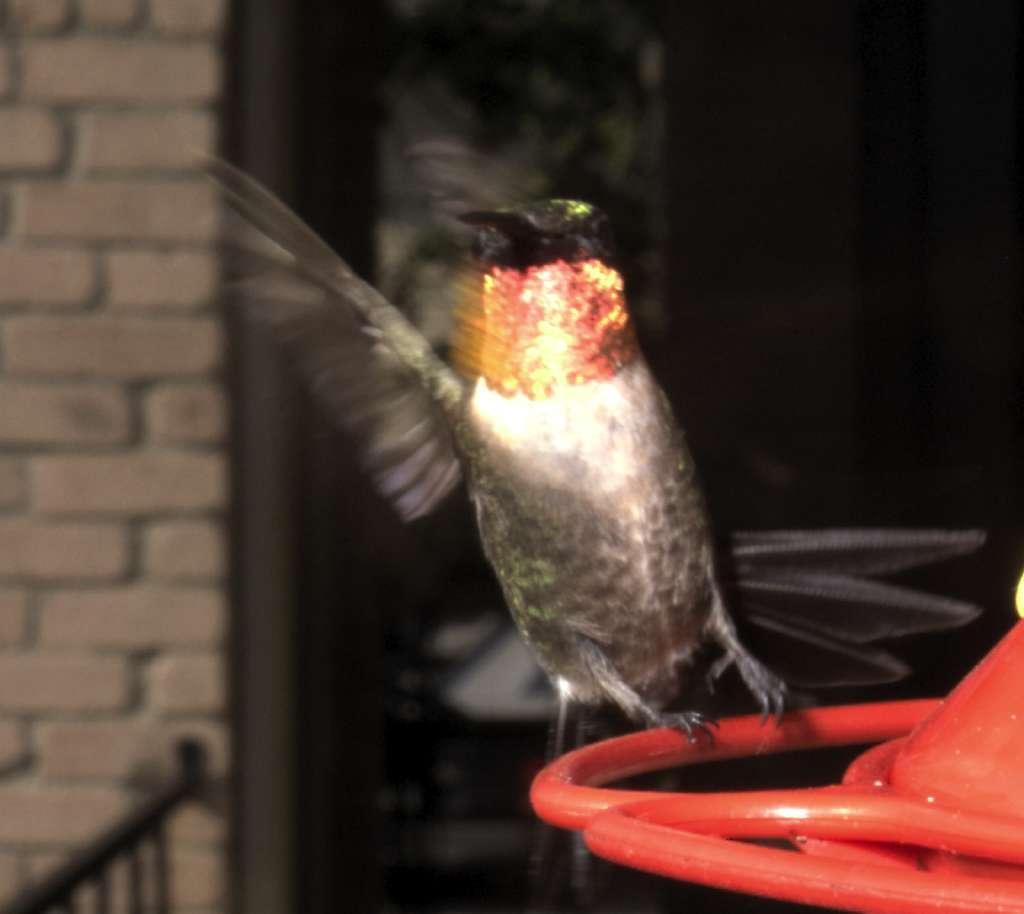Please provide a concise description of this image. In this image there is a bird sitting on a object behind that there are pillars and fence of a building. 